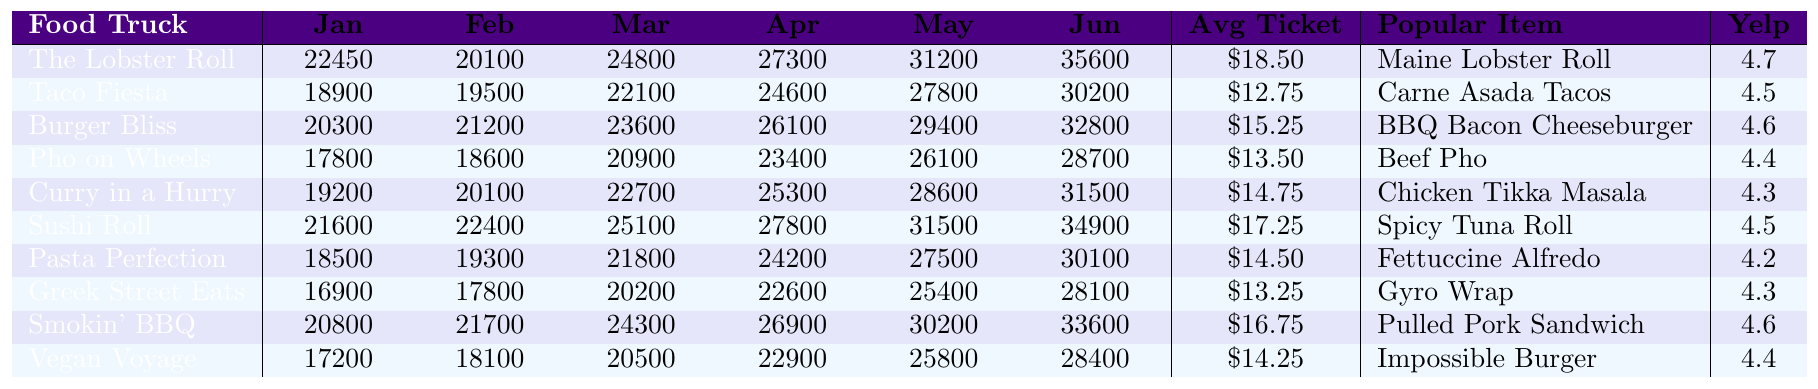What is the total revenue generated by "The Lobster Roll" in June? The table shows that "The Lobster Roll" generated a revenue of 35600 in June.
Answer: 35600 What is the average ticket price of "Taco Fiesta"? The table lists the average ticket price for "Taco Fiesta" as $12.75.
Answer: $12.75 Which food truck had the highest revenue in May? By comparing the revenues for May across all food trucks, "The Lobster Roll" with 31200 had the highest revenue.
Answer: The Lobster Roll What is the difference in revenue between "Pho on Wheels" in January and June? "Pho on Wheels" generated 17800 in January and 28700 in June. The difference is 28700 - 17800 = 10900.
Answer: 10900 Which food truck has the lowest Yelp rating, and what is that rating? The food truck with the lowest Yelp rating is "Pasta Perfection," which has a rating of 4.2.
Answer: Pasta Perfection, 4.2 What was the total revenue for "Sushi Roll" from January to March? The revenues for "Sushi Roll" from January to March are 21600 (January) + 22400 (February) + 25100 (March) = 69100.
Answer: 69100 Is "Curry in a Hurry" more popular than "Greek Street Eats" based on the average ticket price? "Curry in a Hurry" has an average ticket price of $14.75 while "Greek Street Eats" has $13.25. Therefore, "Curry in a Hurry" is indeed more popular in terms of price.
Answer: Yes What is the revenue trend for "Vegan Voyage" from January to June? Observing the revenue figures: January (17200), February (18100), March (20500), April (22900), May (25800), June (28400). The trend shows a consistent increase each month.
Answer: Increasing What is the average revenue of all food trucks in April? To find the average, sum up all April revenues: 27300 + 24600 + 26100 + 23400 + 25300 + 27800 + 24200 + 22600 + 26900 + 22900 = 251200. Then divide by 10 (the number of food trucks), which gives 25120.
Answer: 25120 Which cuisine has the highest average revenue in January among the food trucks? The revenues in January are as follows: 22450 (Seafood), 18900 (Mexican), 20300 (American), 17800 (Vietnamese), 19200 (Indian), 21600 (Japanese), 18500 (Italian), 16900 (Greek), 20800 (Barbecue), and 17200 (Vegan). The highest is 22450 for Seafood.
Answer: Seafood 